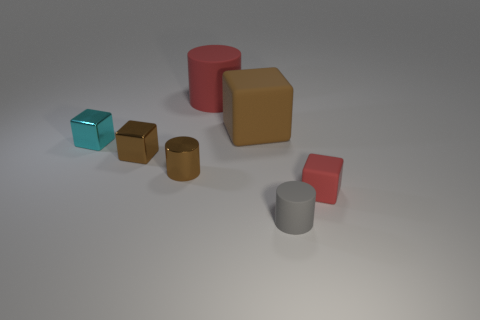What size is the cube that is in front of the tiny shiny block that is in front of the tiny cyan metallic object?
Keep it short and to the point. Small. What size is the other cube that is the same material as the small cyan block?
Provide a succinct answer. Small. What is the shape of the small object that is to the right of the tiny brown metallic block and to the left of the small gray rubber object?
Offer a terse response. Cylinder. Is the number of tiny red rubber things that are behind the big matte cylinder the same as the number of cyan things?
Provide a succinct answer. No. How many objects are either gray objects or things in front of the brown cylinder?
Provide a short and direct response. 2. Is there a blue thing of the same shape as the large red matte thing?
Give a very brief answer. No. Are there an equal number of matte objects in front of the big brown matte block and large matte objects right of the tiny gray cylinder?
Ensure brevity in your answer.  No. Is there any other thing that is the same size as the cyan cube?
Offer a very short reply. Yes. What number of brown objects are either big matte objects or big metallic cylinders?
Provide a succinct answer. 1. What number of other gray matte things are the same size as the gray object?
Keep it short and to the point. 0. 